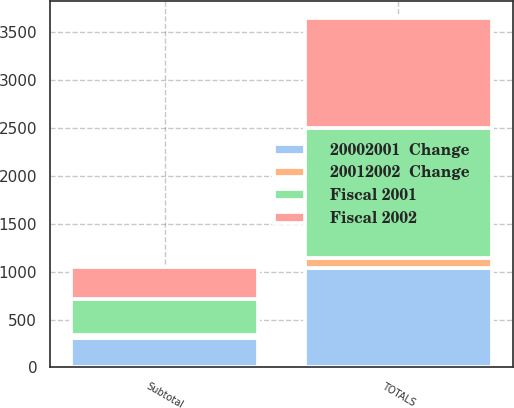Convert chart to OTSL. <chart><loc_0><loc_0><loc_500><loc_500><stacked_bar_chart><ecel><fcel>Subtotal<fcel>TOTALS<nl><fcel>20002001  Change<fcel>311.5<fcel>1037.3<nl><fcel>20012002  Change<fcel>30<fcel>100<nl><fcel>Fiscal 2002<fcel>328.6<fcel>1148.4<nl><fcel>Fiscal 2001<fcel>374.6<fcel>1358.3<nl></chart> 